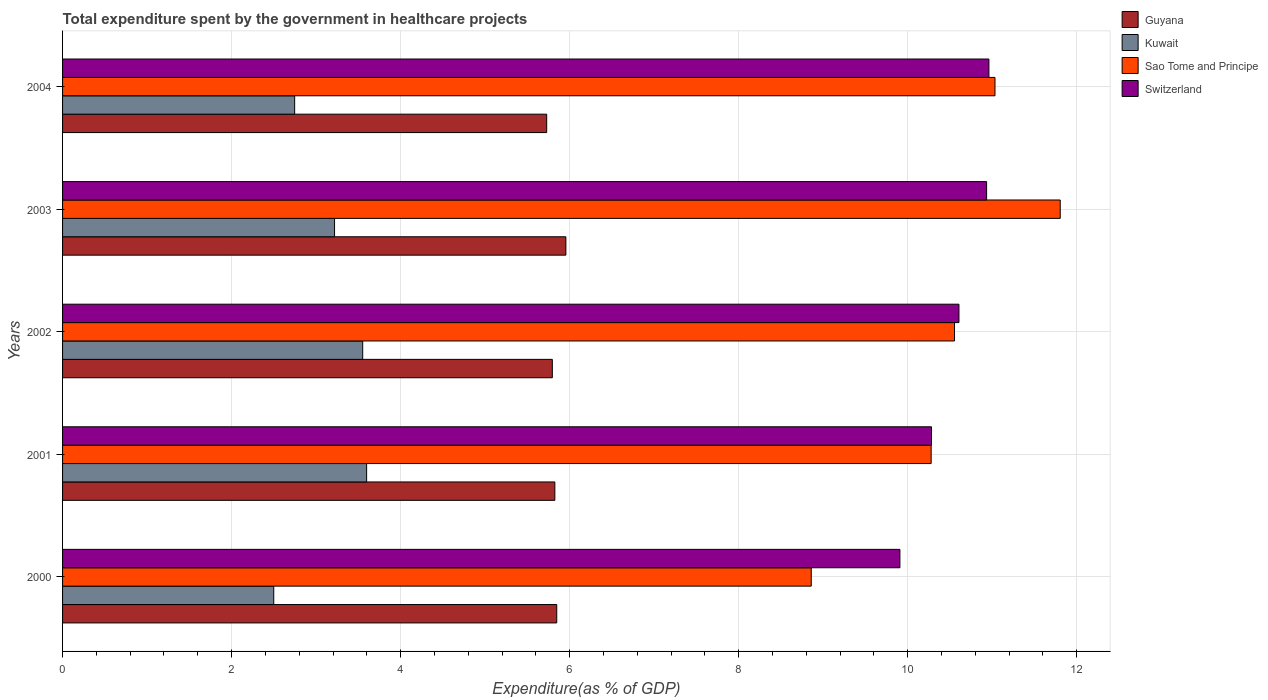How many groups of bars are there?
Keep it short and to the point. 5. Are the number of bars per tick equal to the number of legend labels?
Keep it short and to the point. Yes. In how many cases, is the number of bars for a given year not equal to the number of legend labels?
Your response must be concise. 0. What is the total expenditure spent by the government in healthcare projects in Sao Tome and Principe in 2002?
Provide a succinct answer. 10.55. Across all years, what is the maximum total expenditure spent by the government in healthcare projects in Kuwait?
Offer a very short reply. 3.6. Across all years, what is the minimum total expenditure spent by the government in healthcare projects in Switzerland?
Offer a terse response. 9.91. In which year was the total expenditure spent by the government in healthcare projects in Sao Tome and Principe maximum?
Offer a very short reply. 2003. In which year was the total expenditure spent by the government in healthcare projects in Switzerland minimum?
Provide a succinct answer. 2000. What is the total total expenditure spent by the government in healthcare projects in Sao Tome and Principe in the graph?
Give a very brief answer. 52.53. What is the difference between the total expenditure spent by the government in healthcare projects in Kuwait in 2000 and that in 2003?
Your response must be concise. -0.72. What is the difference between the total expenditure spent by the government in healthcare projects in Guyana in 2001 and the total expenditure spent by the government in healthcare projects in Sao Tome and Principe in 2003?
Ensure brevity in your answer.  -5.98. What is the average total expenditure spent by the government in healthcare projects in Guyana per year?
Provide a short and direct response. 5.83. In the year 2004, what is the difference between the total expenditure spent by the government in healthcare projects in Switzerland and total expenditure spent by the government in healthcare projects in Kuwait?
Offer a very short reply. 8.21. What is the ratio of the total expenditure spent by the government in healthcare projects in Guyana in 2001 to that in 2003?
Provide a short and direct response. 0.98. What is the difference between the highest and the second highest total expenditure spent by the government in healthcare projects in Sao Tome and Principe?
Give a very brief answer. 0.77. What is the difference between the highest and the lowest total expenditure spent by the government in healthcare projects in Switzerland?
Your response must be concise. 1.05. What does the 3rd bar from the top in 2003 represents?
Provide a short and direct response. Kuwait. What does the 4th bar from the bottom in 2002 represents?
Your answer should be compact. Switzerland. How many bars are there?
Provide a short and direct response. 20. What is the difference between two consecutive major ticks on the X-axis?
Make the answer very short. 2. Are the values on the major ticks of X-axis written in scientific E-notation?
Keep it short and to the point. No. Does the graph contain any zero values?
Give a very brief answer. No. Where does the legend appear in the graph?
Make the answer very short. Top right. How are the legend labels stacked?
Give a very brief answer. Vertical. What is the title of the graph?
Your answer should be compact. Total expenditure spent by the government in healthcare projects. Does "Japan" appear as one of the legend labels in the graph?
Your answer should be very brief. No. What is the label or title of the X-axis?
Give a very brief answer. Expenditure(as % of GDP). What is the label or title of the Y-axis?
Ensure brevity in your answer.  Years. What is the Expenditure(as % of GDP) of Guyana in 2000?
Make the answer very short. 5.85. What is the Expenditure(as % of GDP) of Kuwait in 2000?
Give a very brief answer. 2.5. What is the Expenditure(as % of GDP) of Sao Tome and Principe in 2000?
Make the answer very short. 8.86. What is the Expenditure(as % of GDP) of Switzerland in 2000?
Offer a terse response. 9.91. What is the Expenditure(as % of GDP) of Guyana in 2001?
Your answer should be compact. 5.82. What is the Expenditure(as % of GDP) of Kuwait in 2001?
Your answer should be compact. 3.6. What is the Expenditure(as % of GDP) in Sao Tome and Principe in 2001?
Make the answer very short. 10.28. What is the Expenditure(as % of GDP) in Switzerland in 2001?
Your answer should be very brief. 10.28. What is the Expenditure(as % of GDP) in Guyana in 2002?
Your answer should be compact. 5.8. What is the Expenditure(as % of GDP) of Kuwait in 2002?
Make the answer very short. 3.55. What is the Expenditure(as % of GDP) in Sao Tome and Principe in 2002?
Your response must be concise. 10.55. What is the Expenditure(as % of GDP) of Switzerland in 2002?
Your response must be concise. 10.61. What is the Expenditure(as % of GDP) in Guyana in 2003?
Keep it short and to the point. 5.96. What is the Expenditure(as % of GDP) of Kuwait in 2003?
Make the answer very short. 3.22. What is the Expenditure(as % of GDP) of Sao Tome and Principe in 2003?
Offer a very short reply. 11.81. What is the Expenditure(as % of GDP) in Switzerland in 2003?
Keep it short and to the point. 10.93. What is the Expenditure(as % of GDP) in Guyana in 2004?
Your answer should be compact. 5.73. What is the Expenditure(as % of GDP) of Kuwait in 2004?
Your answer should be very brief. 2.75. What is the Expenditure(as % of GDP) of Sao Tome and Principe in 2004?
Provide a short and direct response. 11.03. What is the Expenditure(as % of GDP) in Switzerland in 2004?
Offer a terse response. 10.96. Across all years, what is the maximum Expenditure(as % of GDP) in Guyana?
Provide a short and direct response. 5.96. Across all years, what is the maximum Expenditure(as % of GDP) of Kuwait?
Make the answer very short. 3.6. Across all years, what is the maximum Expenditure(as % of GDP) in Sao Tome and Principe?
Ensure brevity in your answer.  11.81. Across all years, what is the maximum Expenditure(as % of GDP) of Switzerland?
Offer a very short reply. 10.96. Across all years, what is the minimum Expenditure(as % of GDP) of Guyana?
Your response must be concise. 5.73. Across all years, what is the minimum Expenditure(as % of GDP) of Kuwait?
Give a very brief answer. 2.5. Across all years, what is the minimum Expenditure(as % of GDP) in Sao Tome and Principe?
Provide a short and direct response. 8.86. Across all years, what is the minimum Expenditure(as % of GDP) of Switzerland?
Keep it short and to the point. 9.91. What is the total Expenditure(as % of GDP) in Guyana in the graph?
Give a very brief answer. 29.15. What is the total Expenditure(as % of GDP) of Kuwait in the graph?
Make the answer very short. 15.61. What is the total Expenditure(as % of GDP) in Sao Tome and Principe in the graph?
Offer a terse response. 52.53. What is the total Expenditure(as % of GDP) of Switzerland in the graph?
Offer a terse response. 52.69. What is the difference between the Expenditure(as % of GDP) in Guyana in 2000 and that in 2001?
Make the answer very short. 0.02. What is the difference between the Expenditure(as % of GDP) in Kuwait in 2000 and that in 2001?
Make the answer very short. -1.1. What is the difference between the Expenditure(as % of GDP) of Sao Tome and Principe in 2000 and that in 2001?
Your answer should be very brief. -1.42. What is the difference between the Expenditure(as % of GDP) in Switzerland in 2000 and that in 2001?
Ensure brevity in your answer.  -0.37. What is the difference between the Expenditure(as % of GDP) in Guyana in 2000 and that in 2002?
Keep it short and to the point. 0.05. What is the difference between the Expenditure(as % of GDP) of Kuwait in 2000 and that in 2002?
Your response must be concise. -1.05. What is the difference between the Expenditure(as % of GDP) of Sao Tome and Principe in 2000 and that in 2002?
Your answer should be very brief. -1.7. What is the difference between the Expenditure(as % of GDP) of Switzerland in 2000 and that in 2002?
Offer a very short reply. -0.7. What is the difference between the Expenditure(as % of GDP) in Guyana in 2000 and that in 2003?
Your answer should be very brief. -0.11. What is the difference between the Expenditure(as % of GDP) in Kuwait in 2000 and that in 2003?
Your response must be concise. -0.72. What is the difference between the Expenditure(as % of GDP) in Sao Tome and Principe in 2000 and that in 2003?
Offer a very short reply. -2.95. What is the difference between the Expenditure(as % of GDP) of Switzerland in 2000 and that in 2003?
Your response must be concise. -1.03. What is the difference between the Expenditure(as % of GDP) in Guyana in 2000 and that in 2004?
Keep it short and to the point. 0.12. What is the difference between the Expenditure(as % of GDP) of Kuwait in 2000 and that in 2004?
Keep it short and to the point. -0.25. What is the difference between the Expenditure(as % of GDP) of Sao Tome and Principe in 2000 and that in 2004?
Provide a short and direct response. -2.17. What is the difference between the Expenditure(as % of GDP) of Switzerland in 2000 and that in 2004?
Ensure brevity in your answer.  -1.05. What is the difference between the Expenditure(as % of GDP) of Guyana in 2001 and that in 2002?
Make the answer very short. 0.03. What is the difference between the Expenditure(as % of GDP) in Kuwait in 2001 and that in 2002?
Make the answer very short. 0.05. What is the difference between the Expenditure(as % of GDP) of Sao Tome and Principe in 2001 and that in 2002?
Give a very brief answer. -0.28. What is the difference between the Expenditure(as % of GDP) in Switzerland in 2001 and that in 2002?
Provide a short and direct response. -0.32. What is the difference between the Expenditure(as % of GDP) of Guyana in 2001 and that in 2003?
Offer a terse response. -0.13. What is the difference between the Expenditure(as % of GDP) of Kuwait in 2001 and that in 2003?
Give a very brief answer. 0.38. What is the difference between the Expenditure(as % of GDP) in Sao Tome and Principe in 2001 and that in 2003?
Make the answer very short. -1.53. What is the difference between the Expenditure(as % of GDP) in Switzerland in 2001 and that in 2003?
Provide a succinct answer. -0.65. What is the difference between the Expenditure(as % of GDP) of Guyana in 2001 and that in 2004?
Provide a succinct answer. 0.1. What is the difference between the Expenditure(as % of GDP) of Kuwait in 2001 and that in 2004?
Provide a short and direct response. 0.85. What is the difference between the Expenditure(as % of GDP) in Sao Tome and Principe in 2001 and that in 2004?
Keep it short and to the point. -0.76. What is the difference between the Expenditure(as % of GDP) of Switzerland in 2001 and that in 2004?
Offer a terse response. -0.68. What is the difference between the Expenditure(as % of GDP) in Guyana in 2002 and that in 2003?
Provide a succinct answer. -0.16. What is the difference between the Expenditure(as % of GDP) of Kuwait in 2002 and that in 2003?
Make the answer very short. 0.33. What is the difference between the Expenditure(as % of GDP) in Sao Tome and Principe in 2002 and that in 2003?
Make the answer very short. -1.25. What is the difference between the Expenditure(as % of GDP) of Switzerland in 2002 and that in 2003?
Your response must be concise. -0.33. What is the difference between the Expenditure(as % of GDP) in Guyana in 2002 and that in 2004?
Give a very brief answer. 0.07. What is the difference between the Expenditure(as % of GDP) in Kuwait in 2002 and that in 2004?
Your response must be concise. 0.81. What is the difference between the Expenditure(as % of GDP) in Sao Tome and Principe in 2002 and that in 2004?
Give a very brief answer. -0.48. What is the difference between the Expenditure(as % of GDP) in Switzerland in 2002 and that in 2004?
Provide a succinct answer. -0.35. What is the difference between the Expenditure(as % of GDP) in Guyana in 2003 and that in 2004?
Make the answer very short. 0.23. What is the difference between the Expenditure(as % of GDP) of Kuwait in 2003 and that in 2004?
Your response must be concise. 0.47. What is the difference between the Expenditure(as % of GDP) of Sao Tome and Principe in 2003 and that in 2004?
Ensure brevity in your answer.  0.77. What is the difference between the Expenditure(as % of GDP) in Switzerland in 2003 and that in 2004?
Your answer should be very brief. -0.03. What is the difference between the Expenditure(as % of GDP) in Guyana in 2000 and the Expenditure(as % of GDP) in Kuwait in 2001?
Give a very brief answer. 2.25. What is the difference between the Expenditure(as % of GDP) of Guyana in 2000 and the Expenditure(as % of GDP) of Sao Tome and Principe in 2001?
Offer a terse response. -4.43. What is the difference between the Expenditure(as % of GDP) in Guyana in 2000 and the Expenditure(as % of GDP) in Switzerland in 2001?
Your answer should be very brief. -4.43. What is the difference between the Expenditure(as % of GDP) in Kuwait in 2000 and the Expenditure(as % of GDP) in Sao Tome and Principe in 2001?
Your answer should be compact. -7.78. What is the difference between the Expenditure(as % of GDP) in Kuwait in 2000 and the Expenditure(as % of GDP) in Switzerland in 2001?
Your answer should be compact. -7.78. What is the difference between the Expenditure(as % of GDP) in Sao Tome and Principe in 2000 and the Expenditure(as % of GDP) in Switzerland in 2001?
Your response must be concise. -1.42. What is the difference between the Expenditure(as % of GDP) of Guyana in 2000 and the Expenditure(as % of GDP) of Kuwait in 2002?
Provide a short and direct response. 2.3. What is the difference between the Expenditure(as % of GDP) of Guyana in 2000 and the Expenditure(as % of GDP) of Sao Tome and Principe in 2002?
Give a very brief answer. -4.71. What is the difference between the Expenditure(as % of GDP) of Guyana in 2000 and the Expenditure(as % of GDP) of Switzerland in 2002?
Offer a terse response. -4.76. What is the difference between the Expenditure(as % of GDP) of Kuwait in 2000 and the Expenditure(as % of GDP) of Sao Tome and Principe in 2002?
Offer a very short reply. -8.06. What is the difference between the Expenditure(as % of GDP) in Kuwait in 2000 and the Expenditure(as % of GDP) in Switzerland in 2002?
Your answer should be very brief. -8.11. What is the difference between the Expenditure(as % of GDP) in Sao Tome and Principe in 2000 and the Expenditure(as % of GDP) in Switzerland in 2002?
Provide a succinct answer. -1.75. What is the difference between the Expenditure(as % of GDP) of Guyana in 2000 and the Expenditure(as % of GDP) of Kuwait in 2003?
Provide a short and direct response. 2.63. What is the difference between the Expenditure(as % of GDP) of Guyana in 2000 and the Expenditure(as % of GDP) of Sao Tome and Principe in 2003?
Make the answer very short. -5.96. What is the difference between the Expenditure(as % of GDP) of Guyana in 2000 and the Expenditure(as % of GDP) of Switzerland in 2003?
Offer a terse response. -5.09. What is the difference between the Expenditure(as % of GDP) of Kuwait in 2000 and the Expenditure(as % of GDP) of Sao Tome and Principe in 2003?
Give a very brief answer. -9.31. What is the difference between the Expenditure(as % of GDP) of Kuwait in 2000 and the Expenditure(as % of GDP) of Switzerland in 2003?
Make the answer very short. -8.44. What is the difference between the Expenditure(as % of GDP) of Sao Tome and Principe in 2000 and the Expenditure(as % of GDP) of Switzerland in 2003?
Keep it short and to the point. -2.07. What is the difference between the Expenditure(as % of GDP) of Guyana in 2000 and the Expenditure(as % of GDP) of Kuwait in 2004?
Ensure brevity in your answer.  3.1. What is the difference between the Expenditure(as % of GDP) of Guyana in 2000 and the Expenditure(as % of GDP) of Sao Tome and Principe in 2004?
Your answer should be very brief. -5.19. What is the difference between the Expenditure(as % of GDP) of Guyana in 2000 and the Expenditure(as % of GDP) of Switzerland in 2004?
Offer a terse response. -5.11. What is the difference between the Expenditure(as % of GDP) of Kuwait in 2000 and the Expenditure(as % of GDP) of Sao Tome and Principe in 2004?
Offer a terse response. -8.53. What is the difference between the Expenditure(as % of GDP) in Kuwait in 2000 and the Expenditure(as % of GDP) in Switzerland in 2004?
Offer a terse response. -8.46. What is the difference between the Expenditure(as % of GDP) in Sao Tome and Principe in 2000 and the Expenditure(as % of GDP) in Switzerland in 2004?
Give a very brief answer. -2.1. What is the difference between the Expenditure(as % of GDP) in Guyana in 2001 and the Expenditure(as % of GDP) in Kuwait in 2002?
Make the answer very short. 2.27. What is the difference between the Expenditure(as % of GDP) in Guyana in 2001 and the Expenditure(as % of GDP) in Sao Tome and Principe in 2002?
Provide a succinct answer. -4.73. What is the difference between the Expenditure(as % of GDP) of Guyana in 2001 and the Expenditure(as % of GDP) of Switzerland in 2002?
Ensure brevity in your answer.  -4.78. What is the difference between the Expenditure(as % of GDP) of Kuwait in 2001 and the Expenditure(as % of GDP) of Sao Tome and Principe in 2002?
Keep it short and to the point. -6.96. What is the difference between the Expenditure(as % of GDP) of Kuwait in 2001 and the Expenditure(as % of GDP) of Switzerland in 2002?
Your response must be concise. -7.01. What is the difference between the Expenditure(as % of GDP) in Sao Tome and Principe in 2001 and the Expenditure(as % of GDP) in Switzerland in 2002?
Offer a terse response. -0.33. What is the difference between the Expenditure(as % of GDP) in Guyana in 2001 and the Expenditure(as % of GDP) in Kuwait in 2003?
Provide a short and direct response. 2.61. What is the difference between the Expenditure(as % of GDP) of Guyana in 2001 and the Expenditure(as % of GDP) of Sao Tome and Principe in 2003?
Offer a terse response. -5.98. What is the difference between the Expenditure(as % of GDP) in Guyana in 2001 and the Expenditure(as % of GDP) in Switzerland in 2003?
Provide a short and direct response. -5.11. What is the difference between the Expenditure(as % of GDP) of Kuwait in 2001 and the Expenditure(as % of GDP) of Sao Tome and Principe in 2003?
Give a very brief answer. -8.21. What is the difference between the Expenditure(as % of GDP) of Kuwait in 2001 and the Expenditure(as % of GDP) of Switzerland in 2003?
Your answer should be compact. -7.34. What is the difference between the Expenditure(as % of GDP) in Sao Tome and Principe in 2001 and the Expenditure(as % of GDP) in Switzerland in 2003?
Offer a terse response. -0.66. What is the difference between the Expenditure(as % of GDP) of Guyana in 2001 and the Expenditure(as % of GDP) of Kuwait in 2004?
Provide a short and direct response. 3.08. What is the difference between the Expenditure(as % of GDP) of Guyana in 2001 and the Expenditure(as % of GDP) of Sao Tome and Principe in 2004?
Offer a terse response. -5.21. What is the difference between the Expenditure(as % of GDP) of Guyana in 2001 and the Expenditure(as % of GDP) of Switzerland in 2004?
Provide a short and direct response. -5.14. What is the difference between the Expenditure(as % of GDP) of Kuwait in 2001 and the Expenditure(as % of GDP) of Sao Tome and Principe in 2004?
Keep it short and to the point. -7.44. What is the difference between the Expenditure(as % of GDP) in Kuwait in 2001 and the Expenditure(as % of GDP) in Switzerland in 2004?
Provide a short and direct response. -7.36. What is the difference between the Expenditure(as % of GDP) of Sao Tome and Principe in 2001 and the Expenditure(as % of GDP) of Switzerland in 2004?
Your answer should be compact. -0.68. What is the difference between the Expenditure(as % of GDP) in Guyana in 2002 and the Expenditure(as % of GDP) in Kuwait in 2003?
Give a very brief answer. 2.58. What is the difference between the Expenditure(as % of GDP) in Guyana in 2002 and the Expenditure(as % of GDP) in Sao Tome and Principe in 2003?
Make the answer very short. -6.01. What is the difference between the Expenditure(as % of GDP) in Guyana in 2002 and the Expenditure(as % of GDP) in Switzerland in 2003?
Provide a short and direct response. -5.14. What is the difference between the Expenditure(as % of GDP) of Kuwait in 2002 and the Expenditure(as % of GDP) of Sao Tome and Principe in 2003?
Keep it short and to the point. -8.25. What is the difference between the Expenditure(as % of GDP) in Kuwait in 2002 and the Expenditure(as % of GDP) in Switzerland in 2003?
Keep it short and to the point. -7.38. What is the difference between the Expenditure(as % of GDP) of Sao Tome and Principe in 2002 and the Expenditure(as % of GDP) of Switzerland in 2003?
Provide a succinct answer. -0.38. What is the difference between the Expenditure(as % of GDP) in Guyana in 2002 and the Expenditure(as % of GDP) in Kuwait in 2004?
Keep it short and to the point. 3.05. What is the difference between the Expenditure(as % of GDP) in Guyana in 2002 and the Expenditure(as % of GDP) in Sao Tome and Principe in 2004?
Ensure brevity in your answer.  -5.24. What is the difference between the Expenditure(as % of GDP) of Guyana in 2002 and the Expenditure(as % of GDP) of Switzerland in 2004?
Your answer should be compact. -5.17. What is the difference between the Expenditure(as % of GDP) of Kuwait in 2002 and the Expenditure(as % of GDP) of Sao Tome and Principe in 2004?
Offer a very short reply. -7.48. What is the difference between the Expenditure(as % of GDP) in Kuwait in 2002 and the Expenditure(as % of GDP) in Switzerland in 2004?
Ensure brevity in your answer.  -7.41. What is the difference between the Expenditure(as % of GDP) of Sao Tome and Principe in 2002 and the Expenditure(as % of GDP) of Switzerland in 2004?
Your answer should be very brief. -0.41. What is the difference between the Expenditure(as % of GDP) of Guyana in 2003 and the Expenditure(as % of GDP) of Kuwait in 2004?
Your answer should be very brief. 3.21. What is the difference between the Expenditure(as % of GDP) of Guyana in 2003 and the Expenditure(as % of GDP) of Sao Tome and Principe in 2004?
Offer a very short reply. -5.08. What is the difference between the Expenditure(as % of GDP) in Guyana in 2003 and the Expenditure(as % of GDP) in Switzerland in 2004?
Keep it short and to the point. -5.01. What is the difference between the Expenditure(as % of GDP) in Kuwait in 2003 and the Expenditure(as % of GDP) in Sao Tome and Principe in 2004?
Provide a short and direct response. -7.81. What is the difference between the Expenditure(as % of GDP) of Kuwait in 2003 and the Expenditure(as % of GDP) of Switzerland in 2004?
Offer a very short reply. -7.74. What is the difference between the Expenditure(as % of GDP) in Sao Tome and Principe in 2003 and the Expenditure(as % of GDP) in Switzerland in 2004?
Offer a very short reply. 0.84. What is the average Expenditure(as % of GDP) of Guyana per year?
Provide a succinct answer. 5.83. What is the average Expenditure(as % of GDP) of Kuwait per year?
Your response must be concise. 3.12. What is the average Expenditure(as % of GDP) of Sao Tome and Principe per year?
Ensure brevity in your answer.  10.51. What is the average Expenditure(as % of GDP) in Switzerland per year?
Provide a succinct answer. 10.54. In the year 2000, what is the difference between the Expenditure(as % of GDP) of Guyana and Expenditure(as % of GDP) of Kuwait?
Offer a terse response. 3.35. In the year 2000, what is the difference between the Expenditure(as % of GDP) in Guyana and Expenditure(as % of GDP) in Sao Tome and Principe?
Ensure brevity in your answer.  -3.01. In the year 2000, what is the difference between the Expenditure(as % of GDP) in Guyana and Expenditure(as % of GDP) in Switzerland?
Offer a terse response. -4.06. In the year 2000, what is the difference between the Expenditure(as % of GDP) of Kuwait and Expenditure(as % of GDP) of Sao Tome and Principe?
Your response must be concise. -6.36. In the year 2000, what is the difference between the Expenditure(as % of GDP) of Kuwait and Expenditure(as % of GDP) of Switzerland?
Your answer should be very brief. -7.41. In the year 2000, what is the difference between the Expenditure(as % of GDP) in Sao Tome and Principe and Expenditure(as % of GDP) in Switzerland?
Offer a terse response. -1.05. In the year 2001, what is the difference between the Expenditure(as % of GDP) of Guyana and Expenditure(as % of GDP) of Kuwait?
Provide a short and direct response. 2.23. In the year 2001, what is the difference between the Expenditure(as % of GDP) in Guyana and Expenditure(as % of GDP) in Sao Tome and Principe?
Your answer should be very brief. -4.45. In the year 2001, what is the difference between the Expenditure(as % of GDP) of Guyana and Expenditure(as % of GDP) of Switzerland?
Your answer should be very brief. -4.46. In the year 2001, what is the difference between the Expenditure(as % of GDP) of Kuwait and Expenditure(as % of GDP) of Sao Tome and Principe?
Keep it short and to the point. -6.68. In the year 2001, what is the difference between the Expenditure(as % of GDP) of Kuwait and Expenditure(as % of GDP) of Switzerland?
Your answer should be compact. -6.68. In the year 2001, what is the difference between the Expenditure(as % of GDP) of Sao Tome and Principe and Expenditure(as % of GDP) of Switzerland?
Ensure brevity in your answer.  -0. In the year 2002, what is the difference between the Expenditure(as % of GDP) in Guyana and Expenditure(as % of GDP) in Kuwait?
Ensure brevity in your answer.  2.24. In the year 2002, what is the difference between the Expenditure(as % of GDP) in Guyana and Expenditure(as % of GDP) in Sao Tome and Principe?
Your answer should be compact. -4.76. In the year 2002, what is the difference between the Expenditure(as % of GDP) in Guyana and Expenditure(as % of GDP) in Switzerland?
Offer a very short reply. -4.81. In the year 2002, what is the difference between the Expenditure(as % of GDP) of Kuwait and Expenditure(as % of GDP) of Sao Tome and Principe?
Provide a succinct answer. -7. In the year 2002, what is the difference between the Expenditure(as % of GDP) in Kuwait and Expenditure(as % of GDP) in Switzerland?
Make the answer very short. -7.06. In the year 2002, what is the difference between the Expenditure(as % of GDP) in Sao Tome and Principe and Expenditure(as % of GDP) in Switzerland?
Your answer should be compact. -0.05. In the year 2003, what is the difference between the Expenditure(as % of GDP) of Guyana and Expenditure(as % of GDP) of Kuwait?
Your response must be concise. 2.74. In the year 2003, what is the difference between the Expenditure(as % of GDP) of Guyana and Expenditure(as % of GDP) of Sao Tome and Principe?
Give a very brief answer. -5.85. In the year 2003, what is the difference between the Expenditure(as % of GDP) of Guyana and Expenditure(as % of GDP) of Switzerland?
Ensure brevity in your answer.  -4.98. In the year 2003, what is the difference between the Expenditure(as % of GDP) of Kuwait and Expenditure(as % of GDP) of Sao Tome and Principe?
Keep it short and to the point. -8.59. In the year 2003, what is the difference between the Expenditure(as % of GDP) of Kuwait and Expenditure(as % of GDP) of Switzerland?
Make the answer very short. -7.72. In the year 2003, what is the difference between the Expenditure(as % of GDP) of Sao Tome and Principe and Expenditure(as % of GDP) of Switzerland?
Ensure brevity in your answer.  0.87. In the year 2004, what is the difference between the Expenditure(as % of GDP) of Guyana and Expenditure(as % of GDP) of Kuwait?
Provide a short and direct response. 2.98. In the year 2004, what is the difference between the Expenditure(as % of GDP) of Guyana and Expenditure(as % of GDP) of Sao Tome and Principe?
Offer a very short reply. -5.3. In the year 2004, what is the difference between the Expenditure(as % of GDP) in Guyana and Expenditure(as % of GDP) in Switzerland?
Your answer should be very brief. -5.23. In the year 2004, what is the difference between the Expenditure(as % of GDP) of Kuwait and Expenditure(as % of GDP) of Sao Tome and Principe?
Provide a short and direct response. -8.29. In the year 2004, what is the difference between the Expenditure(as % of GDP) in Kuwait and Expenditure(as % of GDP) in Switzerland?
Your answer should be compact. -8.21. In the year 2004, what is the difference between the Expenditure(as % of GDP) in Sao Tome and Principe and Expenditure(as % of GDP) in Switzerland?
Your answer should be very brief. 0.07. What is the ratio of the Expenditure(as % of GDP) in Guyana in 2000 to that in 2001?
Offer a very short reply. 1. What is the ratio of the Expenditure(as % of GDP) in Kuwait in 2000 to that in 2001?
Provide a short and direct response. 0.69. What is the ratio of the Expenditure(as % of GDP) of Sao Tome and Principe in 2000 to that in 2001?
Give a very brief answer. 0.86. What is the ratio of the Expenditure(as % of GDP) of Switzerland in 2000 to that in 2001?
Make the answer very short. 0.96. What is the ratio of the Expenditure(as % of GDP) of Kuwait in 2000 to that in 2002?
Make the answer very short. 0.7. What is the ratio of the Expenditure(as % of GDP) in Sao Tome and Principe in 2000 to that in 2002?
Your response must be concise. 0.84. What is the ratio of the Expenditure(as % of GDP) in Switzerland in 2000 to that in 2002?
Offer a very short reply. 0.93. What is the ratio of the Expenditure(as % of GDP) of Guyana in 2000 to that in 2003?
Your response must be concise. 0.98. What is the ratio of the Expenditure(as % of GDP) of Kuwait in 2000 to that in 2003?
Keep it short and to the point. 0.78. What is the ratio of the Expenditure(as % of GDP) in Sao Tome and Principe in 2000 to that in 2003?
Keep it short and to the point. 0.75. What is the ratio of the Expenditure(as % of GDP) of Switzerland in 2000 to that in 2003?
Make the answer very short. 0.91. What is the ratio of the Expenditure(as % of GDP) of Guyana in 2000 to that in 2004?
Make the answer very short. 1.02. What is the ratio of the Expenditure(as % of GDP) of Kuwait in 2000 to that in 2004?
Your response must be concise. 0.91. What is the ratio of the Expenditure(as % of GDP) in Sao Tome and Principe in 2000 to that in 2004?
Provide a short and direct response. 0.8. What is the ratio of the Expenditure(as % of GDP) in Switzerland in 2000 to that in 2004?
Keep it short and to the point. 0.9. What is the ratio of the Expenditure(as % of GDP) in Guyana in 2001 to that in 2002?
Your answer should be very brief. 1.01. What is the ratio of the Expenditure(as % of GDP) of Kuwait in 2001 to that in 2002?
Provide a succinct answer. 1.01. What is the ratio of the Expenditure(as % of GDP) of Sao Tome and Principe in 2001 to that in 2002?
Offer a very short reply. 0.97. What is the ratio of the Expenditure(as % of GDP) of Switzerland in 2001 to that in 2002?
Offer a terse response. 0.97. What is the ratio of the Expenditure(as % of GDP) of Guyana in 2001 to that in 2003?
Your answer should be compact. 0.98. What is the ratio of the Expenditure(as % of GDP) in Kuwait in 2001 to that in 2003?
Offer a terse response. 1.12. What is the ratio of the Expenditure(as % of GDP) of Sao Tome and Principe in 2001 to that in 2003?
Provide a short and direct response. 0.87. What is the ratio of the Expenditure(as % of GDP) in Switzerland in 2001 to that in 2003?
Offer a terse response. 0.94. What is the ratio of the Expenditure(as % of GDP) in Guyana in 2001 to that in 2004?
Give a very brief answer. 1.02. What is the ratio of the Expenditure(as % of GDP) in Kuwait in 2001 to that in 2004?
Your response must be concise. 1.31. What is the ratio of the Expenditure(as % of GDP) of Sao Tome and Principe in 2001 to that in 2004?
Your response must be concise. 0.93. What is the ratio of the Expenditure(as % of GDP) of Switzerland in 2001 to that in 2004?
Offer a terse response. 0.94. What is the ratio of the Expenditure(as % of GDP) in Guyana in 2002 to that in 2003?
Offer a terse response. 0.97. What is the ratio of the Expenditure(as % of GDP) in Kuwait in 2002 to that in 2003?
Provide a succinct answer. 1.1. What is the ratio of the Expenditure(as % of GDP) of Sao Tome and Principe in 2002 to that in 2003?
Your response must be concise. 0.89. What is the ratio of the Expenditure(as % of GDP) of Switzerland in 2002 to that in 2003?
Offer a very short reply. 0.97. What is the ratio of the Expenditure(as % of GDP) of Guyana in 2002 to that in 2004?
Make the answer very short. 1.01. What is the ratio of the Expenditure(as % of GDP) of Kuwait in 2002 to that in 2004?
Keep it short and to the point. 1.29. What is the ratio of the Expenditure(as % of GDP) in Sao Tome and Principe in 2002 to that in 2004?
Ensure brevity in your answer.  0.96. What is the ratio of the Expenditure(as % of GDP) of Switzerland in 2002 to that in 2004?
Your answer should be very brief. 0.97. What is the ratio of the Expenditure(as % of GDP) of Guyana in 2003 to that in 2004?
Your answer should be very brief. 1.04. What is the ratio of the Expenditure(as % of GDP) of Kuwait in 2003 to that in 2004?
Ensure brevity in your answer.  1.17. What is the ratio of the Expenditure(as % of GDP) in Sao Tome and Principe in 2003 to that in 2004?
Make the answer very short. 1.07. What is the difference between the highest and the second highest Expenditure(as % of GDP) in Guyana?
Offer a terse response. 0.11. What is the difference between the highest and the second highest Expenditure(as % of GDP) of Kuwait?
Offer a very short reply. 0.05. What is the difference between the highest and the second highest Expenditure(as % of GDP) of Sao Tome and Principe?
Give a very brief answer. 0.77. What is the difference between the highest and the second highest Expenditure(as % of GDP) of Switzerland?
Keep it short and to the point. 0.03. What is the difference between the highest and the lowest Expenditure(as % of GDP) in Guyana?
Offer a terse response. 0.23. What is the difference between the highest and the lowest Expenditure(as % of GDP) of Kuwait?
Your response must be concise. 1.1. What is the difference between the highest and the lowest Expenditure(as % of GDP) of Sao Tome and Principe?
Keep it short and to the point. 2.95. What is the difference between the highest and the lowest Expenditure(as % of GDP) in Switzerland?
Provide a succinct answer. 1.05. 